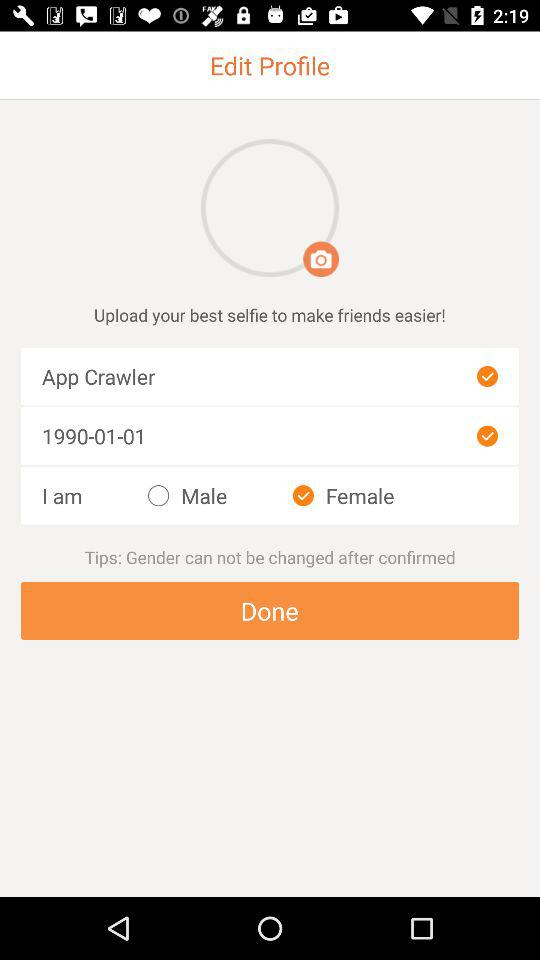What is the gender? The gender is female. 